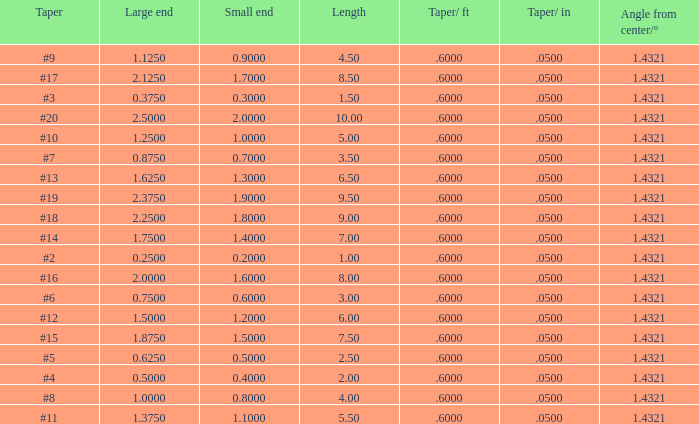Which Taper/in that has a Small end larger than 0.7000000000000001, and a Taper of #19, and a Large end larger than 2.375? None. 